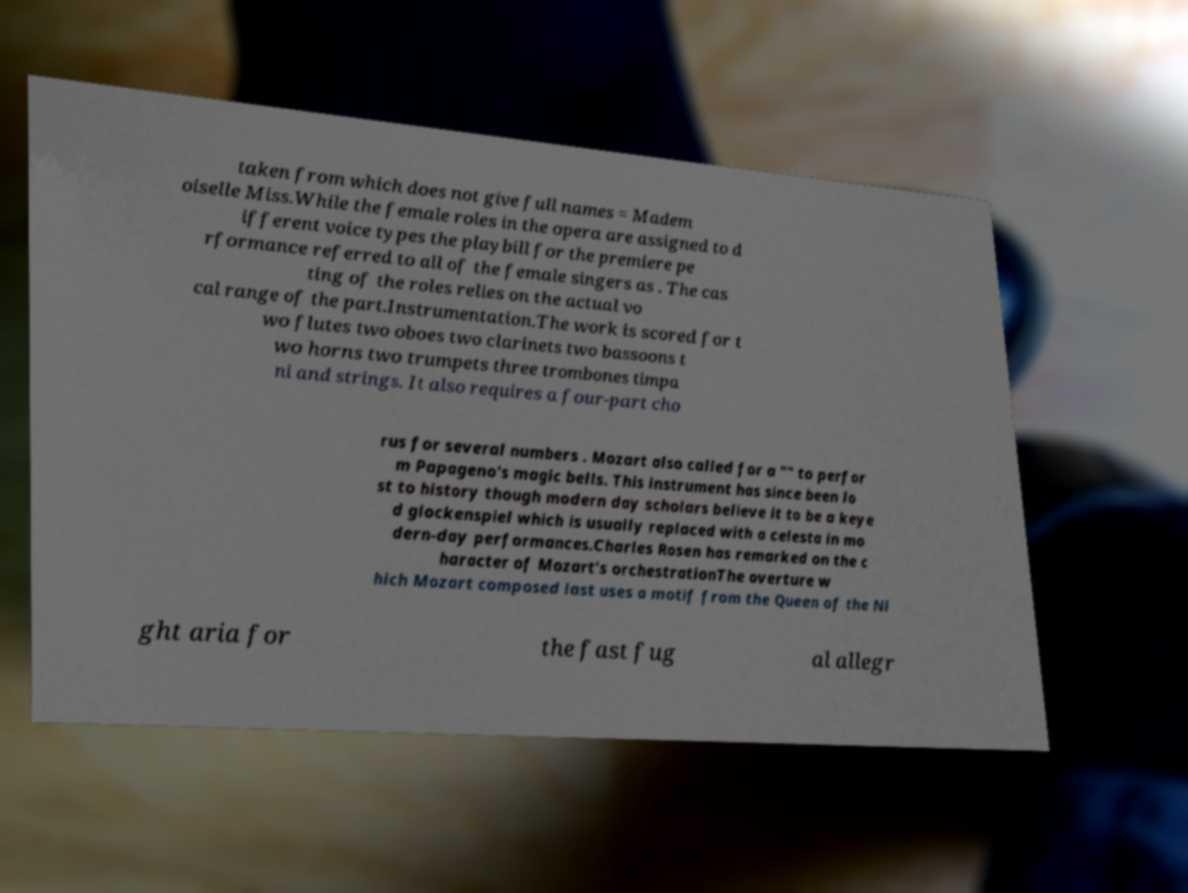Please read and relay the text visible in this image. What does it say? taken from which does not give full names = Madem oiselle Miss.While the female roles in the opera are assigned to d ifferent voice types the playbill for the premiere pe rformance referred to all of the female singers as . The cas ting of the roles relies on the actual vo cal range of the part.Instrumentation.The work is scored for t wo flutes two oboes two clarinets two bassoons t wo horns two trumpets three trombones timpa ni and strings. It also requires a four-part cho rus for several numbers . Mozart also called for a "" to perfor m Papageno's magic bells. This instrument has since been lo st to history though modern day scholars believe it to be a keye d glockenspiel which is usually replaced with a celesta in mo dern-day performances.Charles Rosen has remarked on the c haracter of Mozart's orchestrationThe overture w hich Mozart composed last uses a motif from the Queen of the Ni ght aria for the fast fug al allegr 